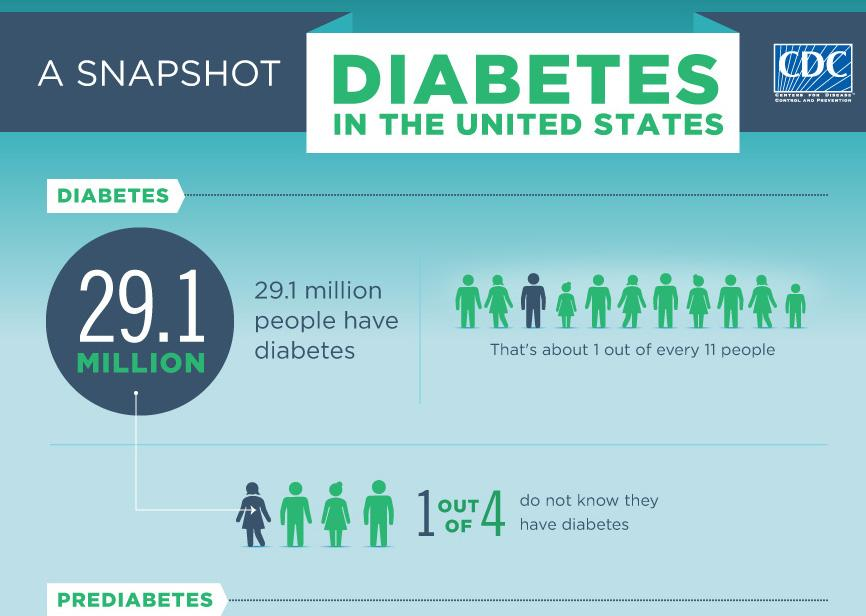Specify some key components in this picture. It has been discussed that a disease known as diabetes is being discussed. According to a recent survey, it was found that 25% of people are unaware that they have diabetes. According to a recent survey, it was found that 75% of the people who know that they have diabetes. 